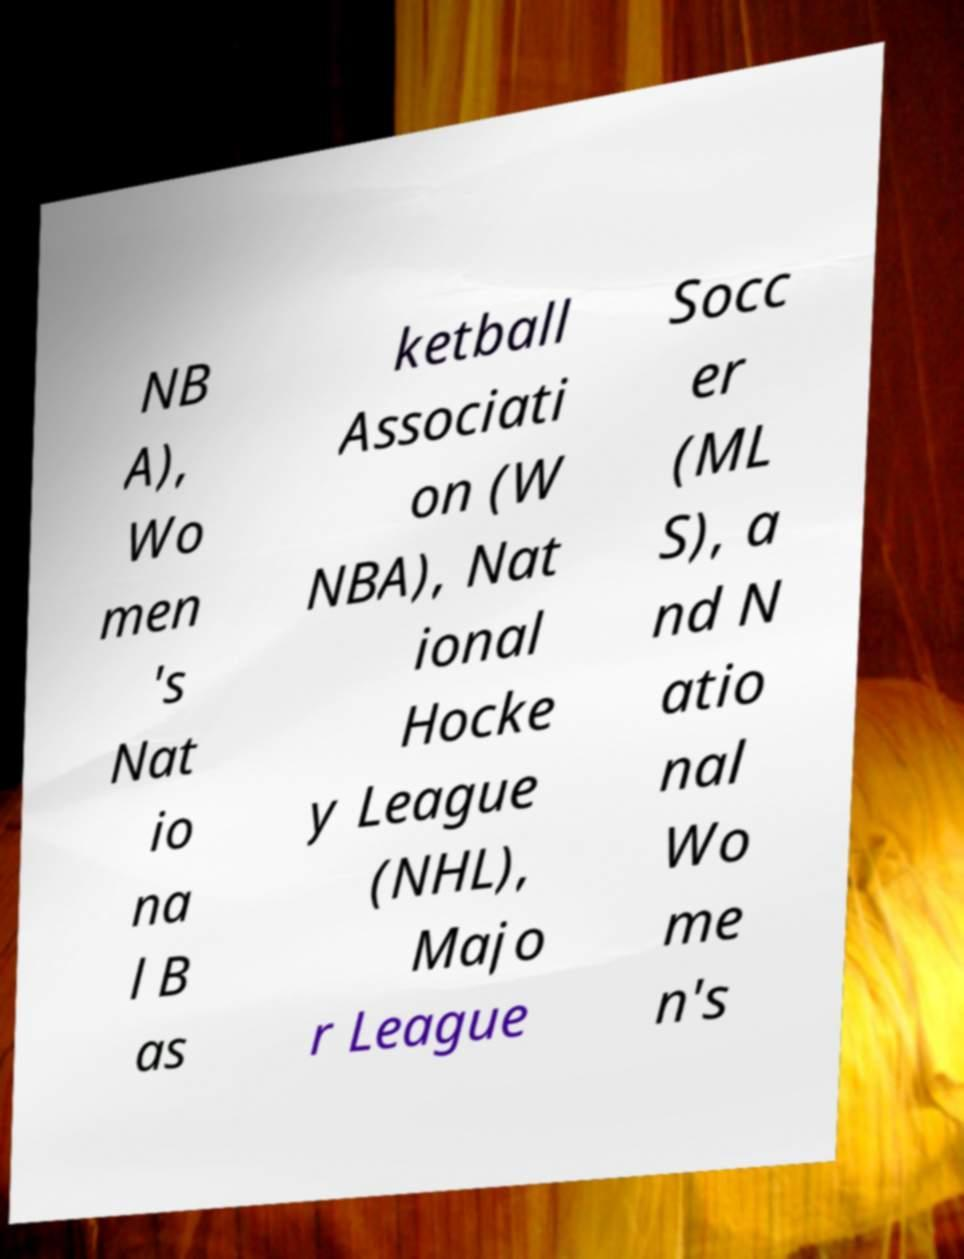Can you accurately transcribe the text from the provided image for me? NB A), Wo men 's Nat io na l B as ketball Associati on (W NBA), Nat ional Hocke y League (NHL), Majo r League Socc er (ML S), a nd N atio nal Wo me n's 